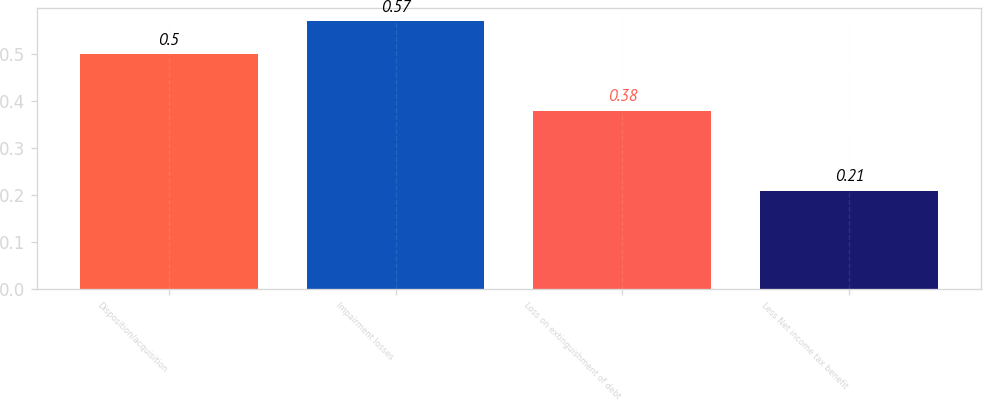<chart> <loc_0><loc_0><loc_500><loc_500><bar_chart><fcel>Disposition/acquisition<fcel>Impairment losses<fcel>Loss on extinguishment of debt<fcel>Less Net income tax benefit<nl><fcel>0.5<fcel>0.57<fcel>0.38<fcel>0.21<nl></chart> 